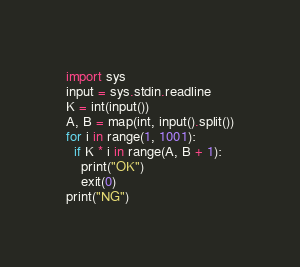<code> <loc_0><loc_0><loc_500><loc_500><_Python_>import sys
input = sys.stdin.readline
K = int(input())
A, B = map(int, input().split())
for i in range(1, 1001):
  if K * i in range(A, B + 1):
    print("OK")
    exit(0)
print("NG")</code> 